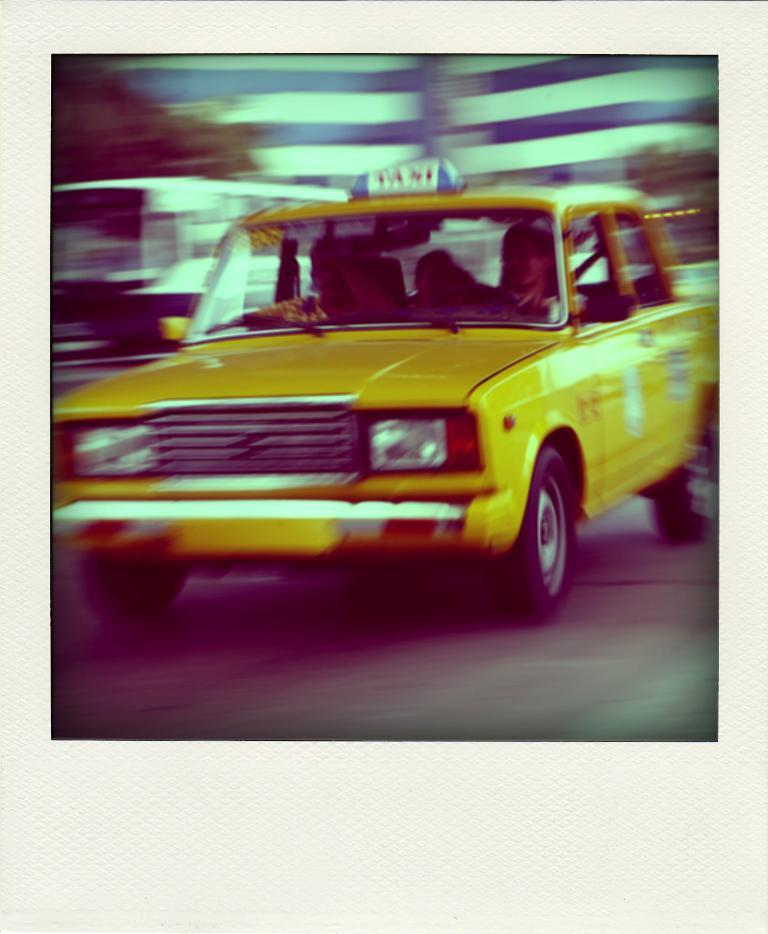<image>
Offer a succinct explanation of the picture presented. As a yellow cab with a Taxi light on top of the car is driving down a road, everything surrounding it is a blur. 